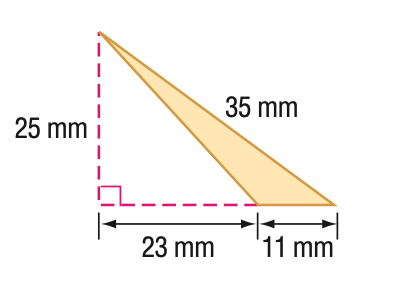Answer the mathemtical geometry problem and directly provide the correct option letter.
Question: Find the perimeter of the triangle. Round to the nearest tenth if necessary.
Choices: A: 70.0 B: 75.0 C: 80.0 D: 85.0 C 